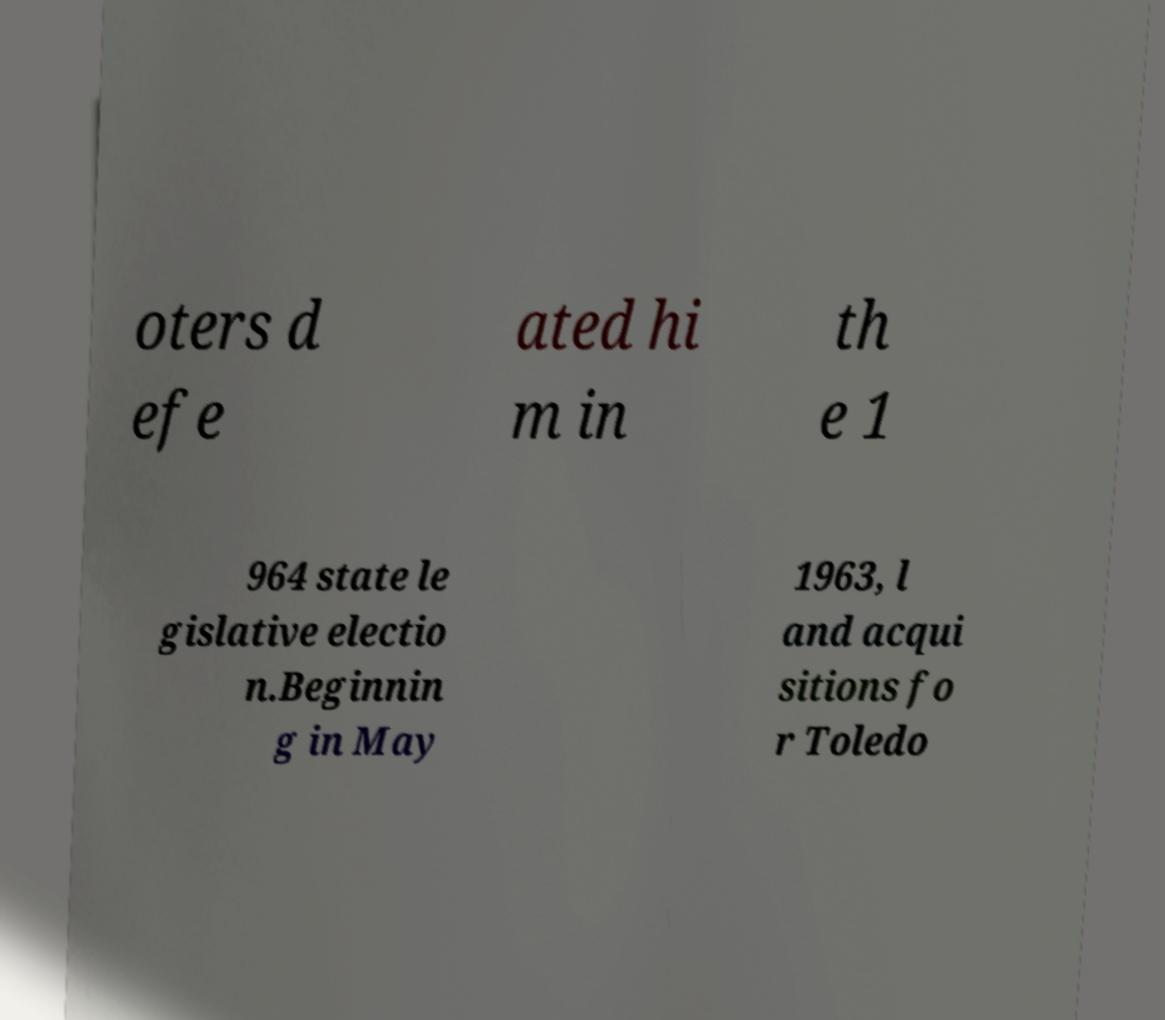Please identify and transcribe the text found in this image. oters d efe ated hi m in th e 1 964 state le gislative electio n.Beginnin g in May 1963, l and acqui sitions fo r Toledo 